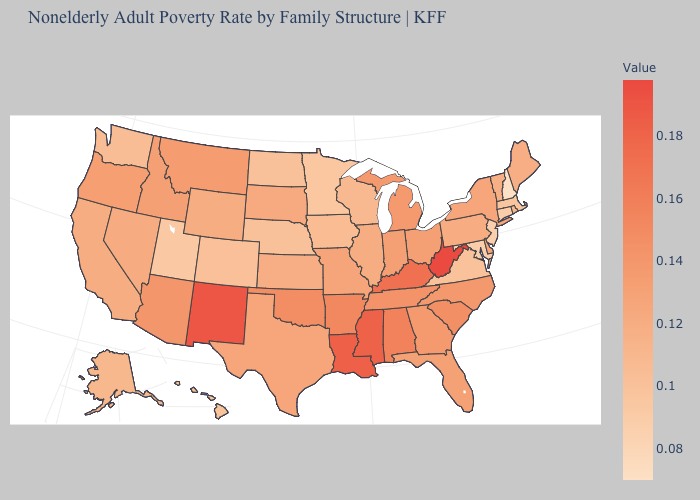Does the map have missing data?
Be succinct. No. Among the states that border Nevada , which have the highest value?
Answer briefly. Arizona. Which states have the lowest value in the USA?
Give a very brief answer. New Hampshire. Is the legend a continuous bar?
Keep it brief. Yes. Which states have the lowest value in the USA?
Keep it brief. New Hampshire. Which states hav the highest value in the West?
Answer briefly. New Mexico. Does the map have missing data?
Short answer required. No. 